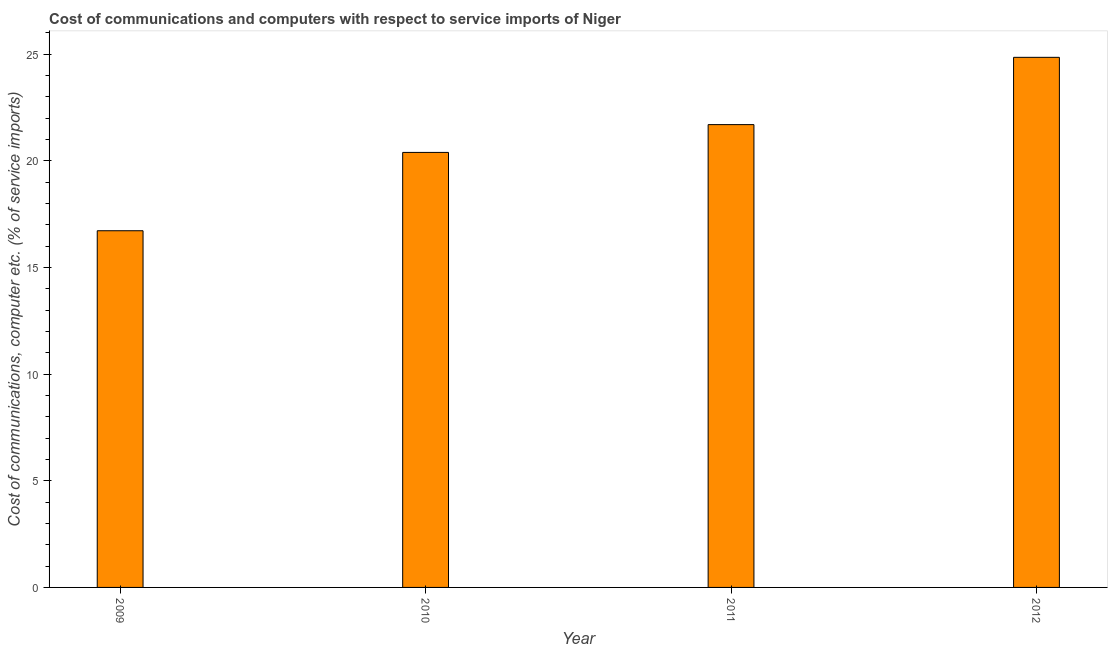Does the graph contain grids?
Make the answer very short. No. What is the title of the graph?
Give a very brief answer. Cost of communications and computers with respect to service imports of Niger. What is the label or title of the X-axis?
Your answer should be very brief. Year. What is the label or title of the Y-axis?
Ensure brevity in your answer.  Cost of communications, computer etc. (% of service imports). What is the cost of communications and computer in 2010?
Provide a succinct answer. 20.4. Across all years, what is the maximum cost of communications and computer?
Offer a terse response. 24.86. Across all years, what is the minimum cost of communications and computer?
Your response must be concise. 16.73. What is the sum of the cost of communications and computer?
Keep it short and to the point. 83.69. What is the difference between the cost of communications and computer in 2011 and 2012?
Your answer should be compact. -3.15. What is the average cost of communications and computer per year?
Offer a terse response. 20.92. What is the median cost of communications and computer?
Give a very brief answer. 21.05. In how many years, is the cost of communications and computer greater than 8 %?
Your answer should be compact. 4. Is the cost of communications and computer in 2011 less than that in 2012?
Provide a short and direct response. Yes. Is the difference between the cost of communications and computer in 2009 and 2012 greater than the difference between any two years?
Ensure brevity in your answer.  Yes. What is the difference between the highest and the second highest cost of communications and computer?
Keep it short and to the point. 3.15. What is the difference between the highest and the lowest cost of communications and computer?
Your response must be concise. 8.13. In how many years, is the cost of communications and computer greater than the average cost of communications and computer taken over all years?
Provide a short and direct response. 2. How many bars are there?
Offer a very short reply. 4. Are all the bars in the graph horizontal?
Your answer should be very brief. No. How many years are there in the graph?
Your answer should be very brief. 4. What is the Cost of communications, computer etc. (% of service imports) of 2009?
Offer a very short reply. 16.73. What is the Cost of communications, computer etc. (% of service imports) in 2010?
Your answer should be compact. 20.4. What is the Cost of communications, computer etc. (% of service imports) in 2011?
Ensure brevity in your answer.  21.7. What is the Cost of communications, computer etc. (% of service imports) of 2012?
Keep it short and to the point. 24.86. What is the difference between the Cost of communications, computer etc. (% of service imports) in 2009 and 2010?
Offer a terse response. -3.67. What is the difference between the Cost of communications, computer etc. (% of service imports) in 2009 and 2011?
Make the answer very short. -4.98. What is the difference between the Cost of communications, computer etc. (% of service imports) in 2009 and 2012?
Provide a short and direct response. -8.13. What is the difference between the Cost of communications, computer etc. (% of service imports) in 2010 and 2011?
Ensure brevity in your answer.  -1.3. What is the difference between the Cost of communications, computer etc. (% of service imports) in 2010 and 2012?
Ensure brevity in your answer.  -4.46. What is the difference between the Cost of communications, computer etc. (% of service imports) in 2011 and 2012?
Your response must be concise. -3.16. What is the ratio of the Cost of communications, computer etc. (% of service imports) in 2009 to that in 2010?
Provide a succinct answer. 0.82. What is the ratio of the Cost of communications, computer etc. (% of service imports) in 2009 to that in 2011?
Your answer should be compact. 0.77. What is the ratio of the Cost of communications, computer etc. (% of service imports) in 2009 to that in 2012?
Provide a short and direct response. 0.67. What is the ratio of the Cost of communications, computer etc. (% of service imports) in 2010 to that in 2011?
Provide a succinct answer. 0.94. What is the ratio of the Cost of communications, computer etc. (% of service imports) in 2010 to that in 2012?
Make the answer very short. 0.82. What is the ratio of the Cost of communications, computer etc. (% of service imports) in 2011 to that in 2012?
Offer a terse response. 0.87. 